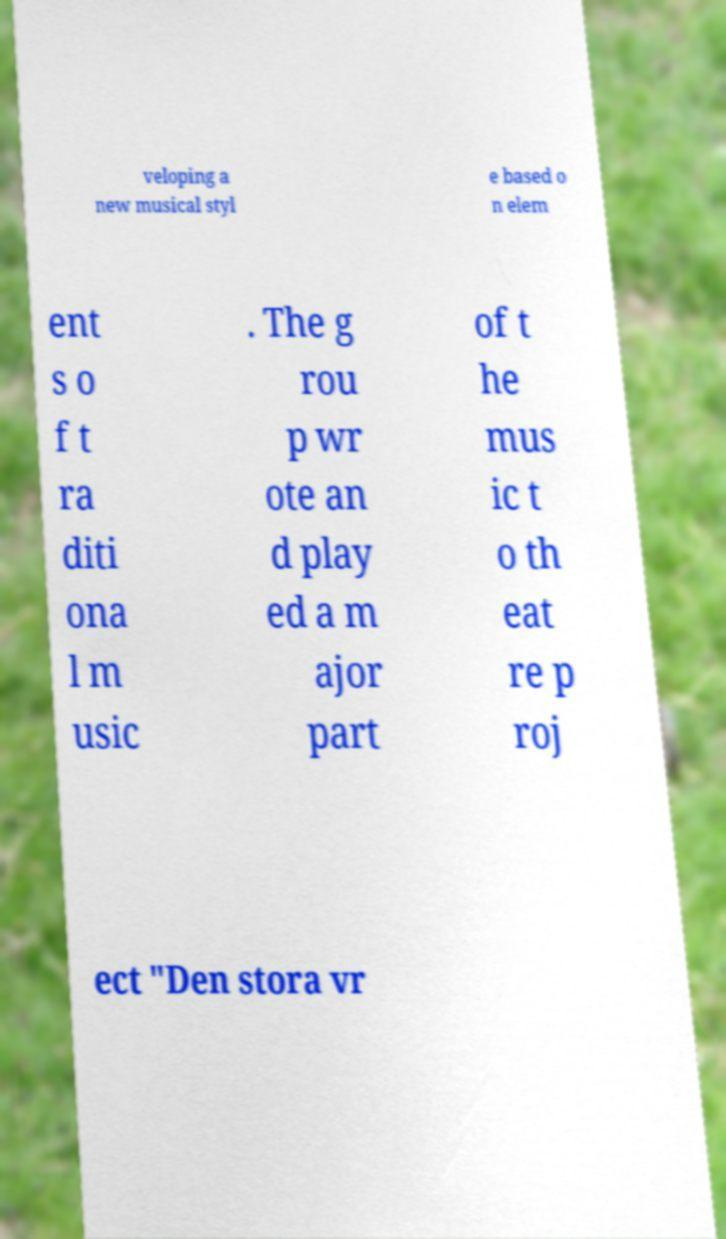Please read and relay the text visible in this image. What does it say? veloping a new musical styl e based o n elem ent s o f t ra diti ona l m usic . The g rou p wr ote an d play ed a m ajor part of t he mus ic t o th eat re p roj ect "Den stora vr 